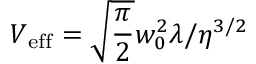Convert formula to latex. <formula><loc_0><loc_0><loc_500><loc_500>V _ { e f f } = \sqrt { \frac { \pi } { 2 } } w _ { 0 } ^ { 2 } \lambda / \eta ^ { 3 / 2 }</formula> 